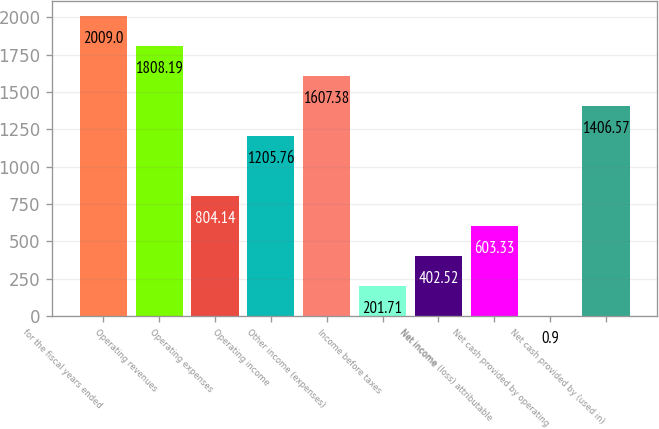Convert chart. <chart><loc_0><loc_0><loc_500><loc_500><bar_chart><fcel>for the fiscal years ended<fcel>Operating revenues<fcel>Operating expenses<fcel>Operating income<fcel>Other income (expenses)<fcel>Income before taxes<fcel>Net income<fcel>Net income (loss) attributable<fcel>Net cash provided by operating<fcel>Net cash provided by (used in)<nl><fcel>2009<fcel>1808.19<fcel>804.14<fcel>1205.76<fcel>1607.38<fcel>201.71<fcel>402.52<fcel>603.33<fcel>0.9<fcel>1406.57<nl></chart> 